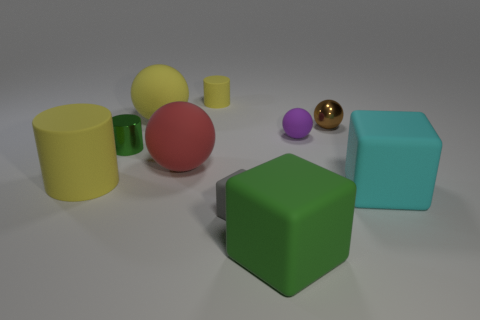There is a cyan object that is the same size as the red sphere; what is its shape?
Your answer should be compact. Cube. How many things are purple cubes or yellow rubber things that are in front of the big red object?
Provide a succinct answer. 1. What number of big yellow matte balls are in front of the yellow matte cylinder on the right side of the rubber cylinder that is in front of the small brown metal object?
Ensure brevity in your answer.  1. There is a small sphere that is the same material as the tiny gray object; what is its color?
Make the answer very short. Purple. Do the yellow matte cylinder right of the green cylinder and the metallic cylinder have the same size?
Offer a terse response. Yes. What number of objects are shiny things or big yellow metal spheres?
Offer a terse response. 2. There is a cube to the left of the green object that is in front of the big rubber block that is behind the tiny matte cube; what is it made of?
Offer a very short reply. Rubber. There is a yellow object that is in front of the brown metallic ball; what is it made of?
Give a very brief answer. Rubber. Is there a yellow matte cylinder that has the same size as the purple ball?
Provide a short and direct response. Yes. Do the block to the right of the purple sphere and the small matte cylinder have the same color?
Ensure brevity in your answer.  No. 